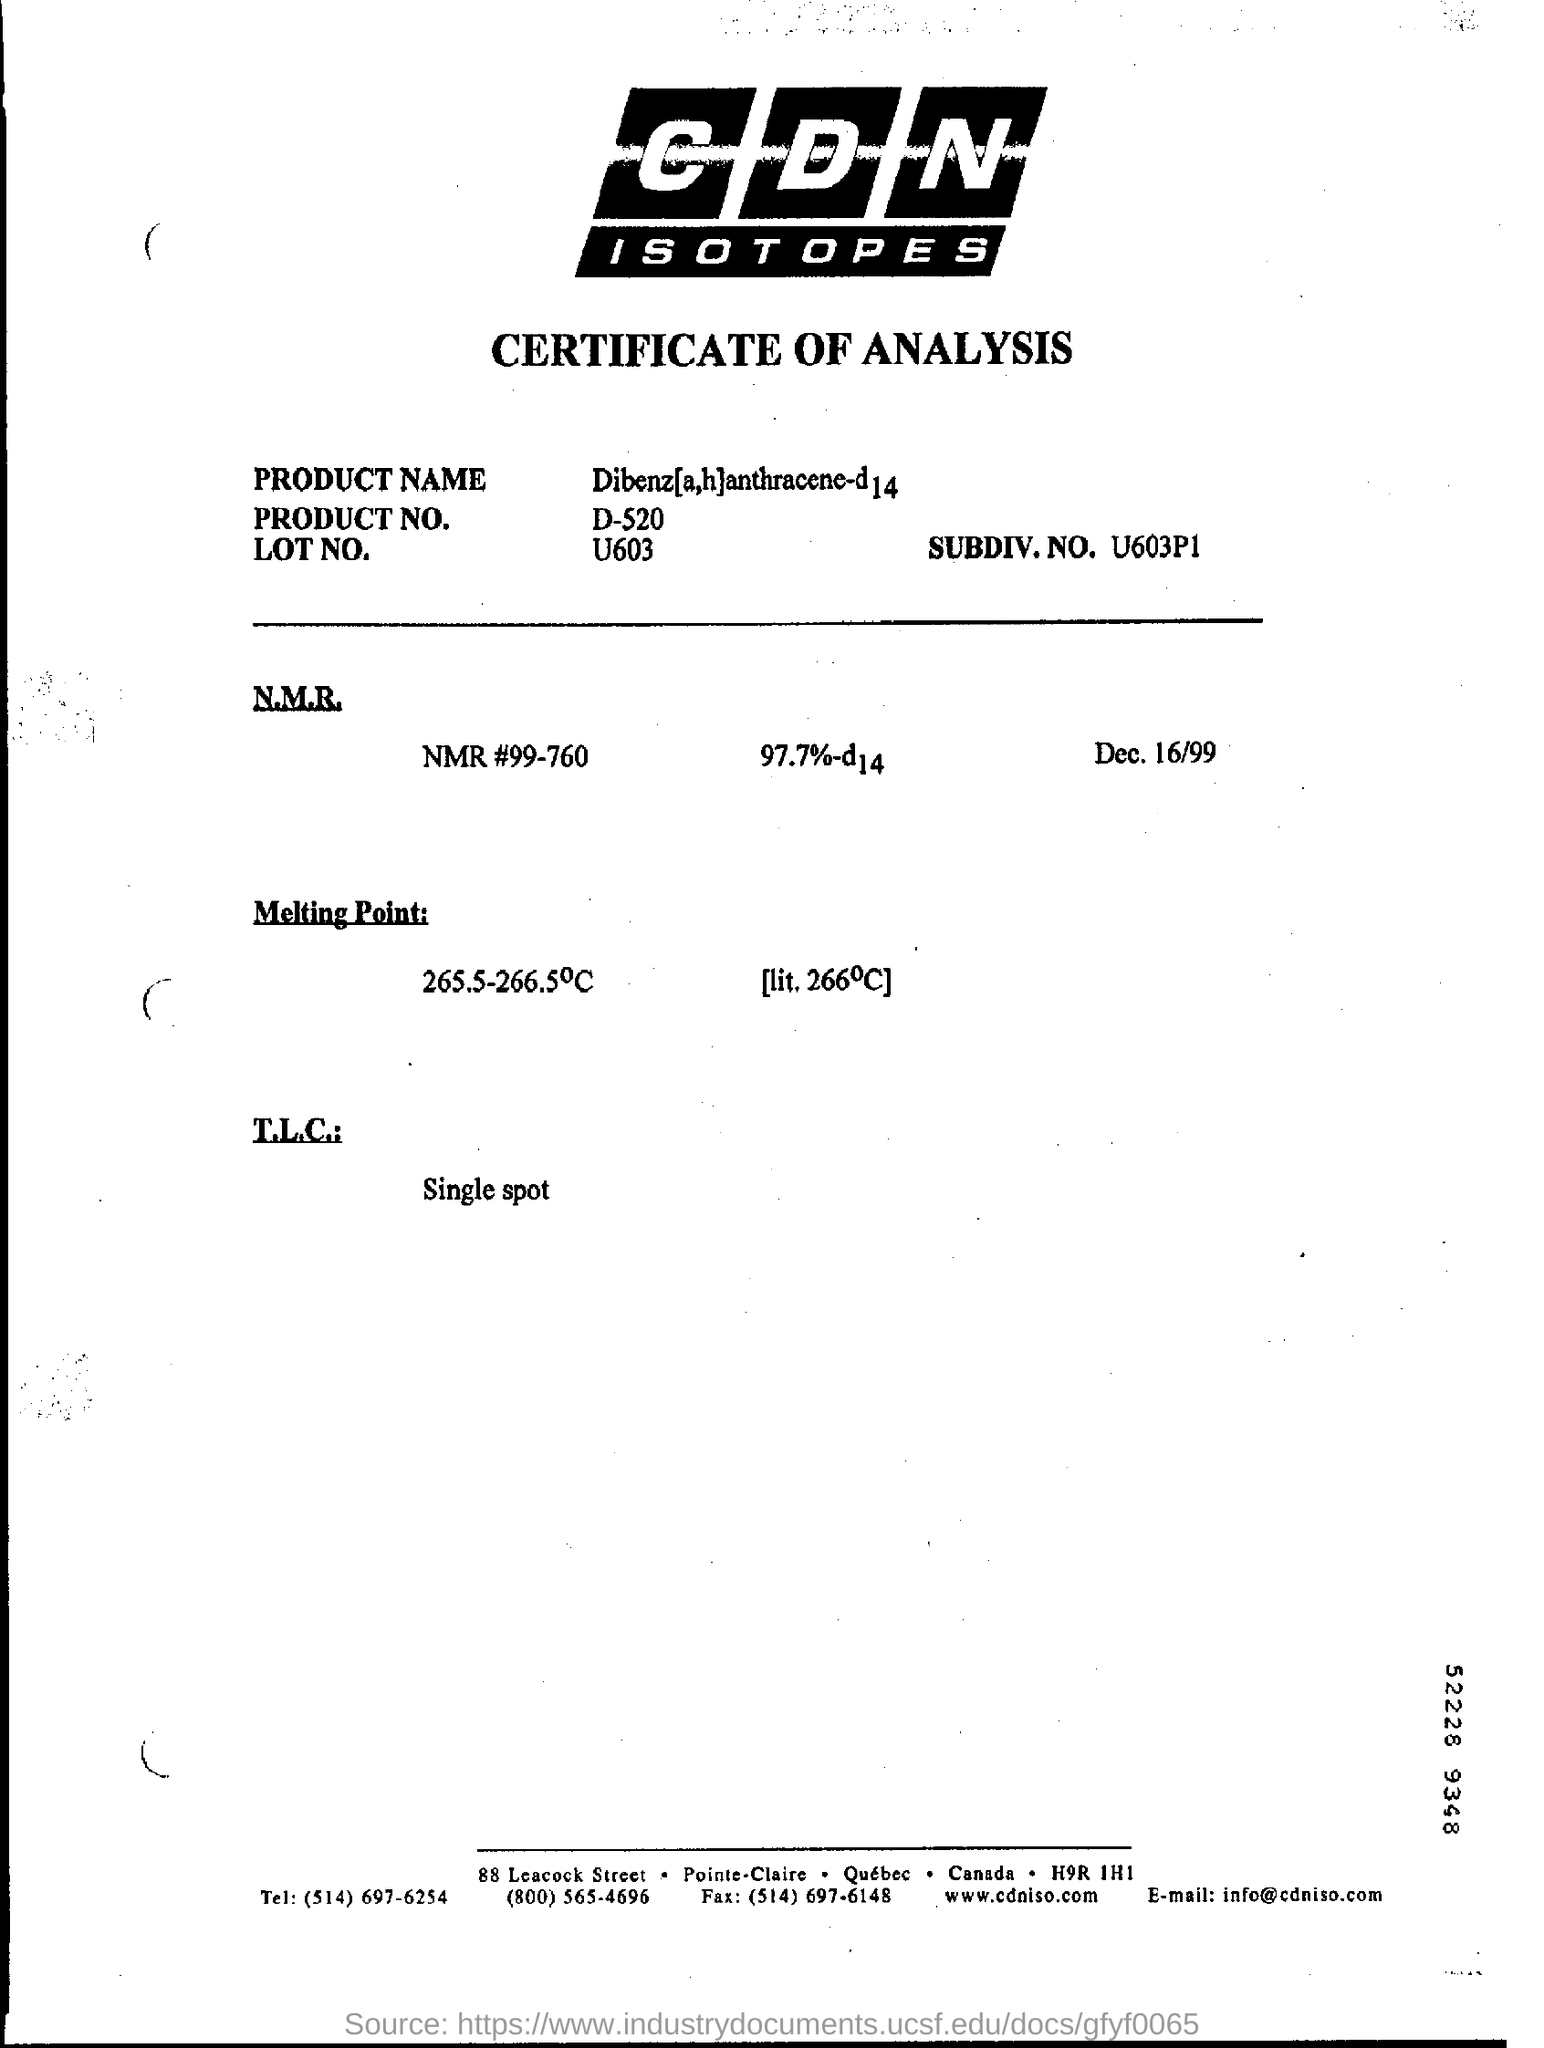What is date mentioned in this page?
Offer a very short reply. Dec. 16/99. What is NMR#
Offer a very short reply. 99-760. Mention what is T.L.C?
Your answer should be compact. Single spot. Find what is subdiv No:
Your response must be concise. U603p1. 